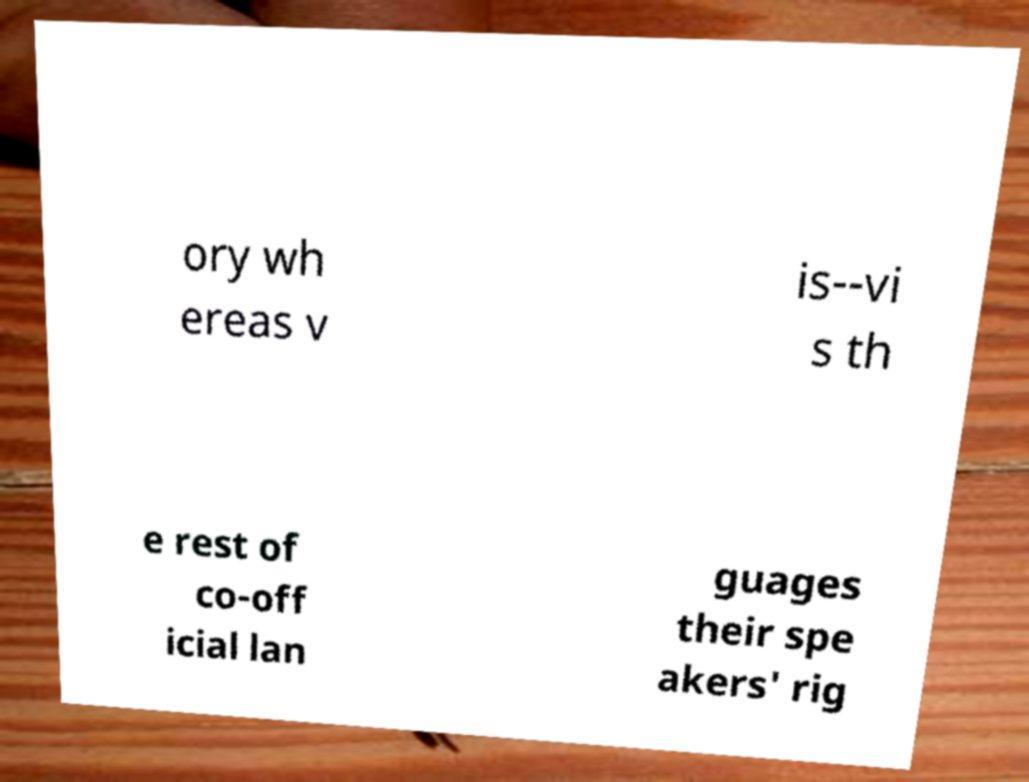Can you accurately transcribe the text from the provided image for me? ory wh ereas v is--vi s th e rest of co-off icial lan guages their spe akers' rig 